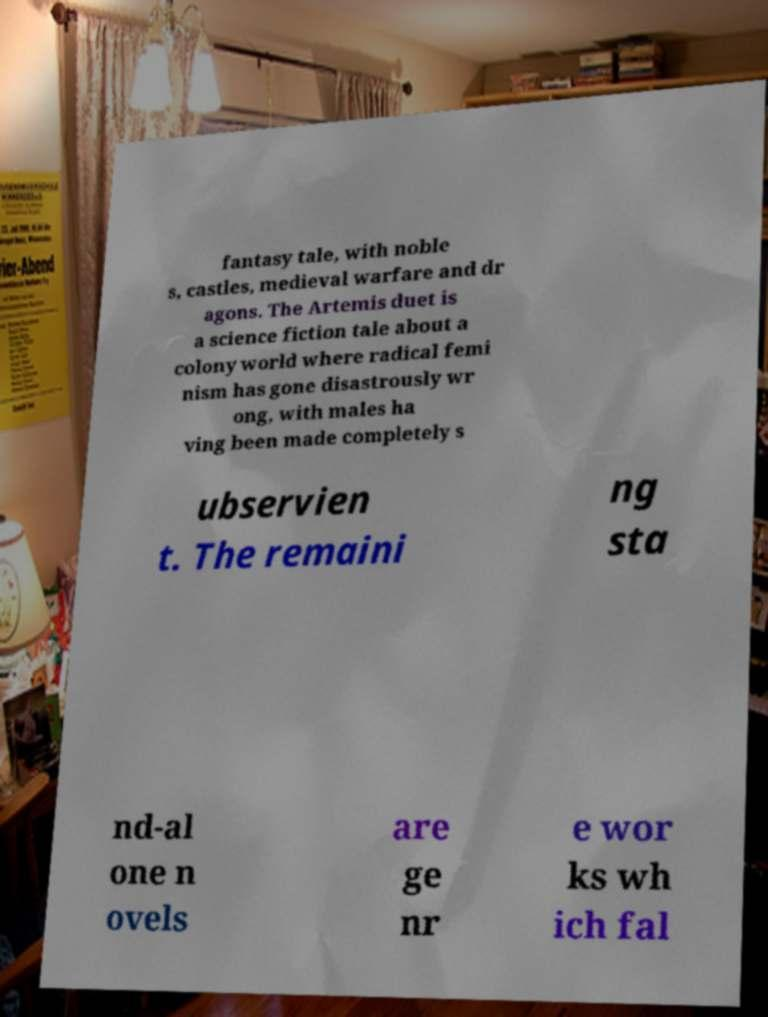Can you read and provide the text displayed in the image?This photo seems to have some interesting text. Can you extract and type it out for me? fantasy tale, with noble s, castles, medieval warfare and dr agons. The Artemis duet is a science fiction tale about a colony world where radical femi nism has gone disastrously wr ong, with males ha ving been made completely s ubservien t. The remaini ng sta nd-al one n ovels are ge nr e wor ks wh ich fal 